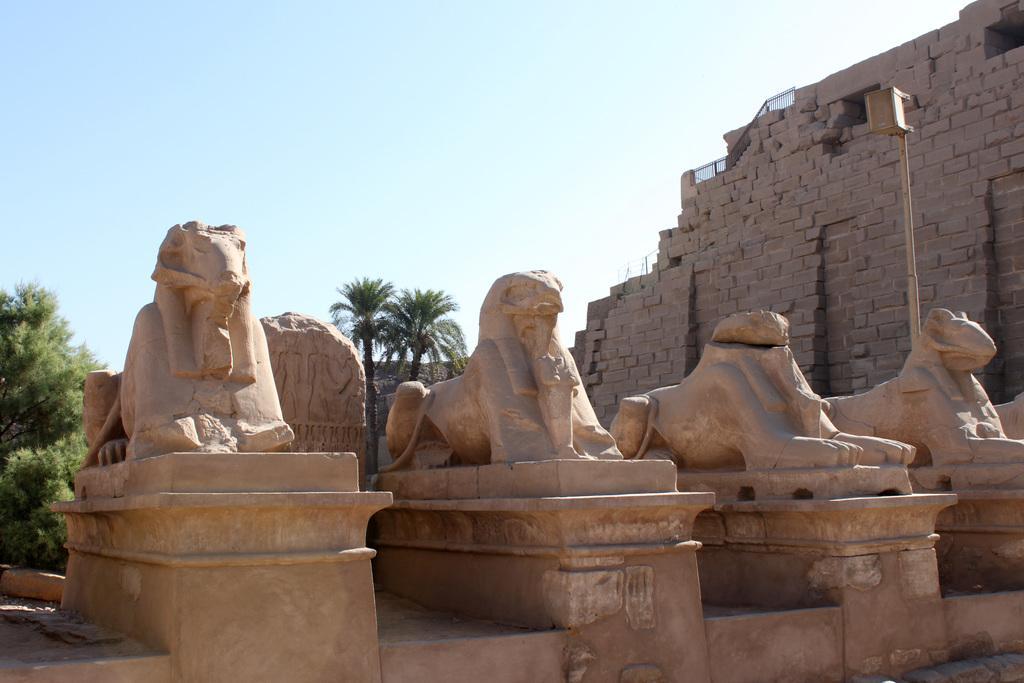In one or two sentences, can you explain what this image depicts? In this image there are sculpture and a monument, in the background there are trees and a blue sky. 